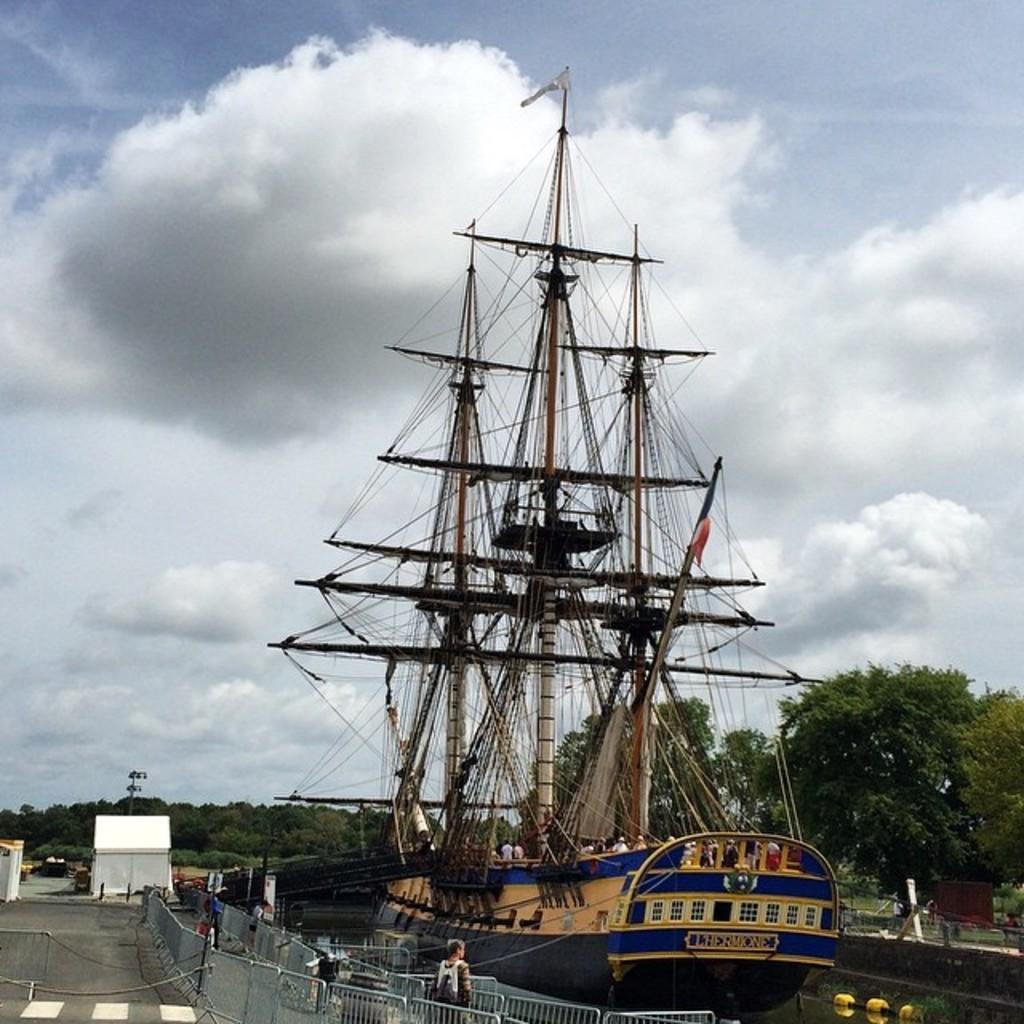Please provide a concise description of this image. In this image there is a ship in a lake, in the left side there is a fencing near the fencing a man is standing, beside the fencing there is a road, in the background there are trees and a cloudy sky. 